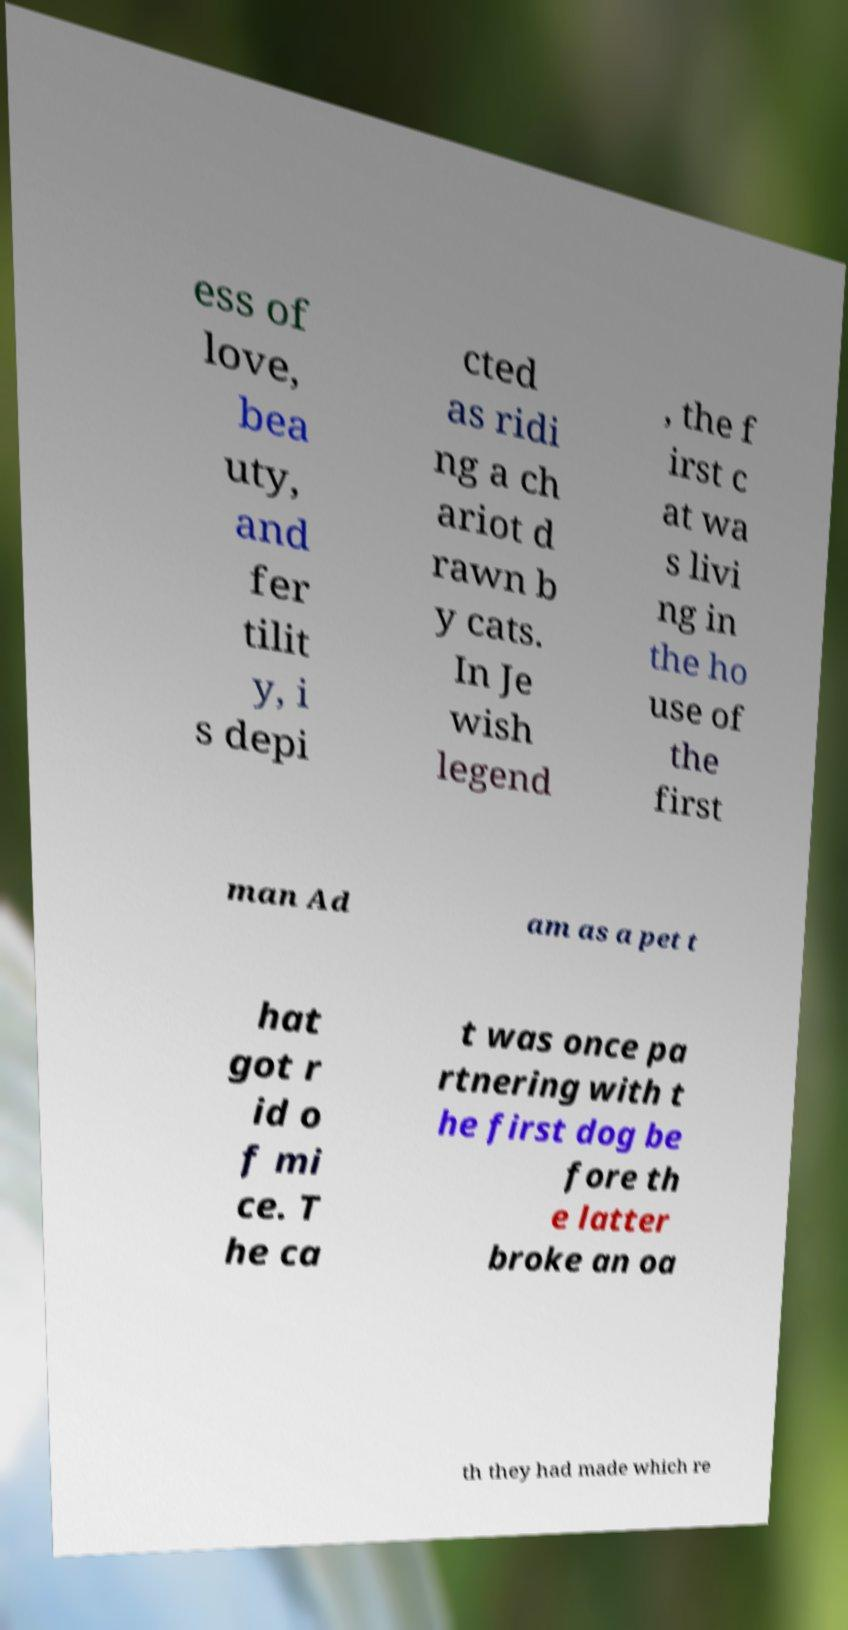Could you extract and type out the text from this image? ess of love, bea uty, and fer tilit y, i s depi cted as ridi ng a ch ariot d rawn b y cats. In Je wish legend , the f irst c at wa s livi ng in the ho use of the first man Ad am as a pet t hat got r id o f mi ce. T he ca t was once pa rtnering with t he first dog be fore th e latter broke an oa th they had made which re 